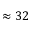Convert formula to latex. <formula><loc_0><loc_0><loc_500><loc_500>\approx 3 2</formula> 